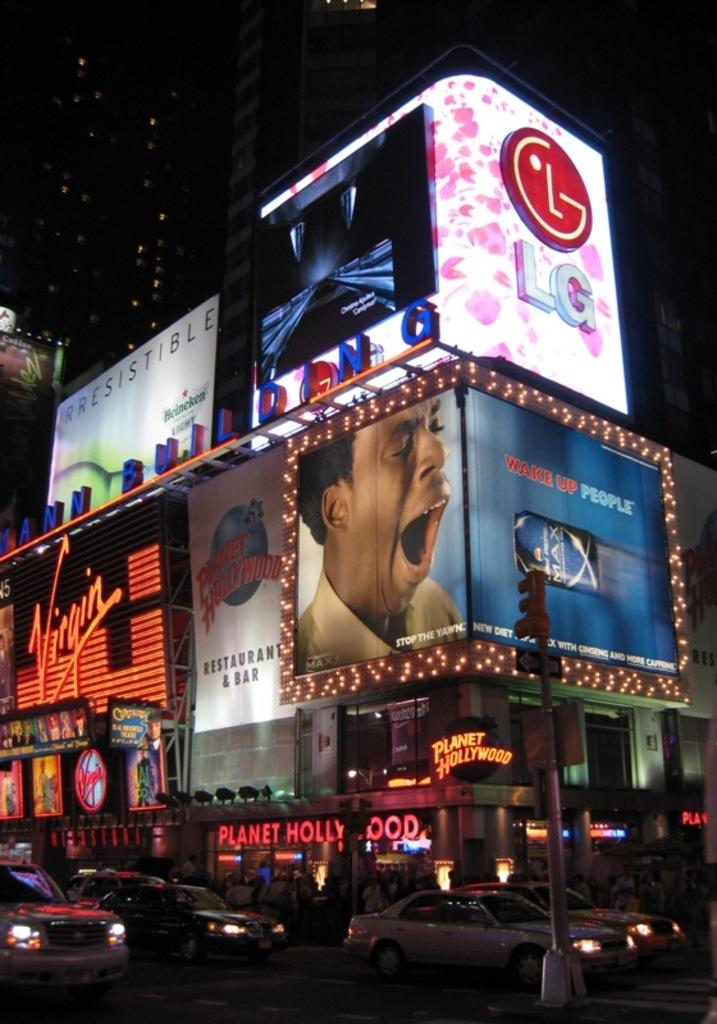<image>
Give a short and clear explanation of the subsequent image. Planet Hollywood with an LG sign on top. 